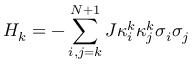Convert formula to latex. <formula><loc_0><loc_0><loc_500><loc_500>{ { H } _ { k } } = - \sum _ { i , j = k } ^ { N + 1 } { J \kappa _ { i } ^ { k } \kappa _ { j } ^ { k } { { \sigma } _ { i } } { { \sigma } _ { j } } }</formula> 